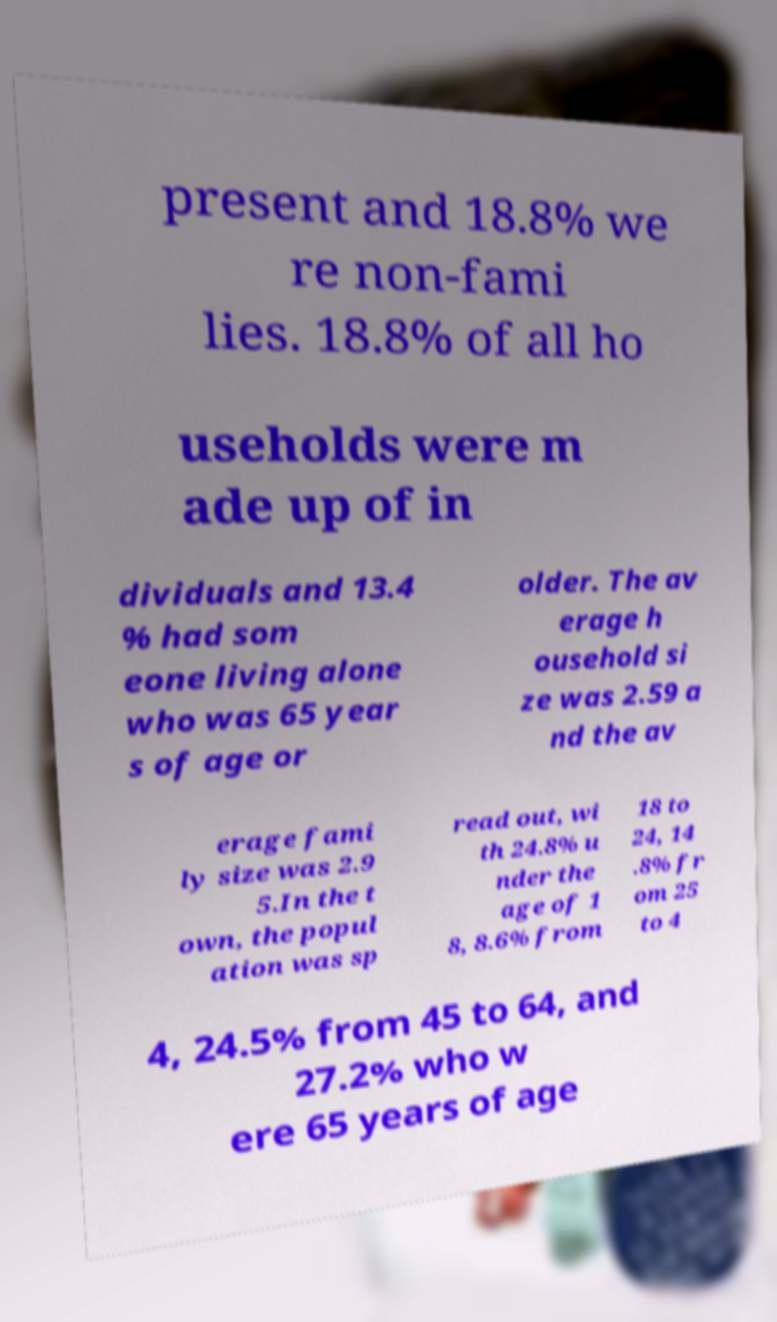Please read and relay the text visible in this image. What does it say? present and 18.8% we re non-fami lies. 18.8% of all ho useholds were m ade up of in dividuals and 13.4 % had som eone living alone who was 65 year s of age or older. The av erage h ousehold si ze was 2.59 a nd the av erage fami ly size was 2.9 5.In the t own, the popul ation was sp read out, wi th 24.8% u nder the age of 1 8, 8.6% from 18 to 24, 14 .8% fr om 25 to 4 4, 24.5% from 45 to 64, and 27.2% who w ere 65 years of age 